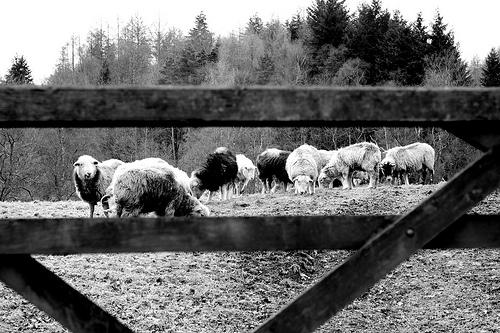Tell me what's notable about the sheep's appearance in the image. Some of the sheep have dark faces and light wool, with expressive facial features, while others have unusual multihued squishfluffy coats. List a few prominent characteristics seen in the image. Sheep with expressive faces, a dark wooden fence with bolts and nails, a grassy ground with hay, and a foggy forest in the background. Retell the situation in the image in a creative manner. A gathering of curious sheep—black and white, woolly and fluffy—feast upon the grass in a mystical pen, guarded by a weathered fence and backed by a hazy, enchanted forest. State what the sheep in the image are doing. The sheep, including black and white ones with expressive faces, are grazing and eating grass, while some are looking to the side or watching others. Describe the fence surrounding the sheep in the image. The wooden fence is dark, old, adorned with bolts, rivets, and nails, and intersects with wood beams at some points, creating triangle shapes. What elements of the image seem unique or interesting? Multihued squishfluffy sheep, a dark fence with smudges, triangle shapes in the negative space, and trees that look frothy in the fog. Mention what can be seen in the background of the image. In the background, there are frothy-looking trees enveloped by fog, forming a large forested area behind the old and dark fence enclosing the sheep. Provide a brief summary of the scene in the image. The image shows a group of sheep, both black and white, grazing in a grassy pen surrounded by a dark wooden fence, with a forest in the background. Describe the ground within the pen where the sheep are grazing. The ground in the pen is a mix of grass and dirt, covered in hay for feeding, with some food of unknown type scattered around the area. Give a detailed description of the area where the sheep are located. The sheep are in a pen with grassy ground and hay, enclosed by a dark fence with bolts and nails, with tall trees and a hill in the background. 